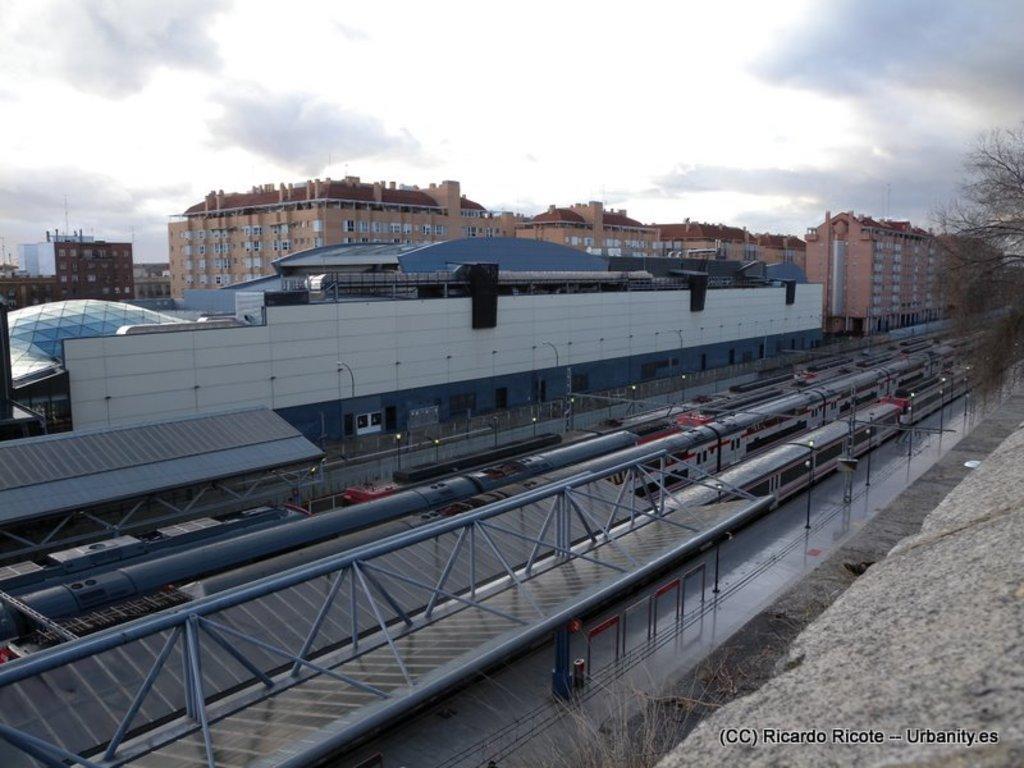Please provide a concise description of this image. In this picture we can see trains, beside these trains we can see a platform, roof, electric poles, fence, trees and in the background we can see buildings, sky. 